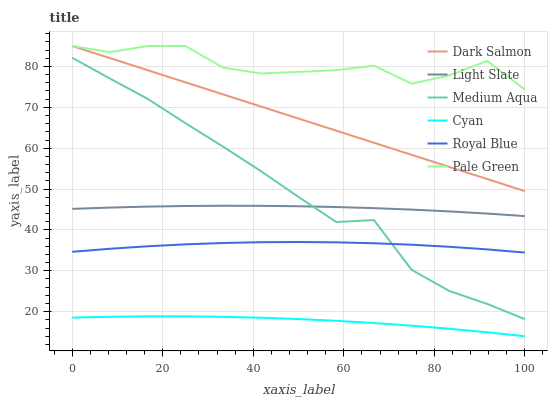Does Cyan have the minimum area under the curve?
Answer yes or no. Yes. Does Pale Green have the maximum area under the curve?
Answer yes or no. Yes. Does Dark Salmon have the minimum area under the curve?
Answer yes or no. No. Does Dark Salmon have the maximum area under the curve?
Answer yes or no. No. Is Dark Salmon the smoothest?
Answer yes or no. Yes. Is Pale Green the roughest?
Answer yes or no. Yes. Is Royal Blue the smoothest?
Answer yes or no. No. Is Royal Blue the roughest?
Answer yes or no. No. Does Cyan have the lowest value?
Answer yes or no. Yes. Does Dark Salmon have the lowest value?
Answer yes or no. No. Does Pale Green have the highest value?
Answer yes or no. Yes. Does Royal Blue have the highest value?
Answer yes or no. No. Is Royal Blue less than Light Slate?
Answer yes or no. Yes. Is Dark Salmon greater than Light Slate?
Answer yes or no. Yes. Does Medium Aqua intersect Light Slate?
Answer yes or no. Yes. Is Medium Aqua less than Light Slate?
Answer yes or no. No. Is Medium Aqua greater than Light Slate?
Answer yes or no. No. Does Royal Blue intersect Light Slate?
Answer yes or no. No. 